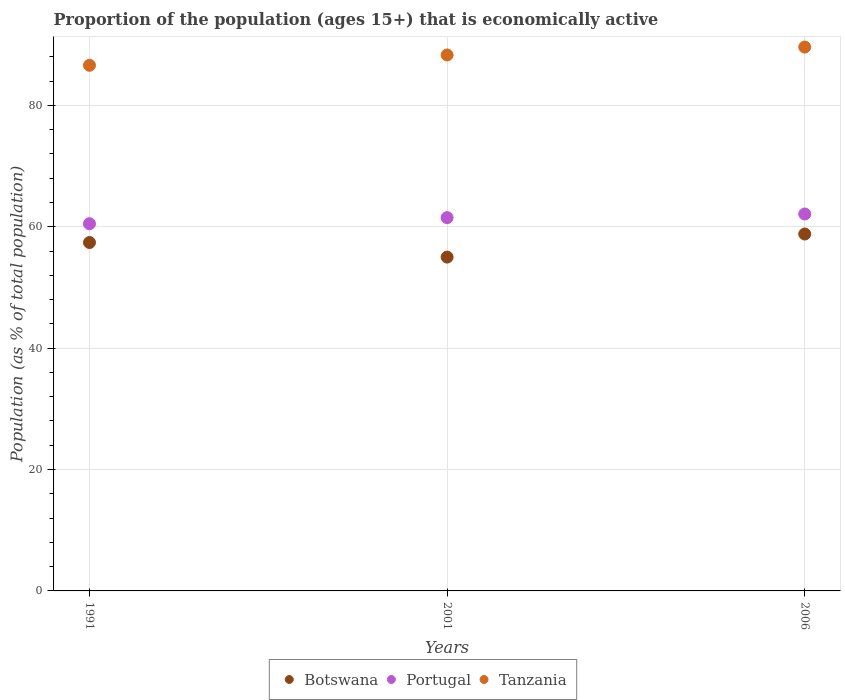How many different coloured dotlines are there?
Your answer should be compact. 3. What is the proportion of the population that is economically active in Botswana in 2006?
Your answer should be very brief. 58.8. Across all years, what is the maximum proportion of the population that is economically active in Tanzania?
Provide a succinct answer. 89.6. Across all years, what is the minimum proportion of the population that is economically active in Portugal?
Keep it short and to the point. 60.5. What is the total proportion of the population that is economically active in Botswana in the graph?
Provide a short and direct response. 171.2. What is the difference between the proportion of the population that is economically active in Tanzania in 2001 and that in 2006?
Make the answer very short. -1.3. What is the difference between the proportion of the population that is economically active in Portugal in 1991 and the proportion of the population that is economically active in Tanzania in 2001?
Make the answer very short. -27.8. What is the average proportion of the population that is economically active in Tanzania per year?
Offer a very short reply. 88.17. In the year 1991, what is the difference between the proportion of the population that is economically active in Botswana and proportion of the population that is economically active in Tanzania?
Provide a succinct answer. -29.2. In how many years, is the proportion of the population that is economically active in Tanzania greater than 8 %?
Ensure brevity in your answer.  3. What is the ratio of the proportion of the population that is economically active in Portugal in 1991 to that in 2006?
Your answer should be compact. 0.97. Is the proportion of the population that is economically active in Botswana in 1991 less than that in 2006?
Ensure brevity in your answer.  Yes. What is the difference between the highest and the second highest proportion of the population that is economically active in Portugal?
Provide a short and direct response. 0.6. What is the difference between the highest and the lowest proportion of the population that is economically active in Botswana?
Ensure brevity in your answer.  3.8. In how many years, is the proportion of the population that is economically active in Tanzania greater than the average proportion of the population that is economically active in Tanzania taken over all years?
Keep it short and to the point. 2. Is the sum of the proportion of the population that is economically active in Portugal in 1991 and 2006 greater than the maximum proportion of the population that is economically active in Botswana across all years?
Offer a very short reply. Yes. How many years are there in the graph?
Your answer should be very brief. 3. What is the difference between two consecutive major ticks on the Y-axis?
Provide a short and direct response. 20. How are the legend labels stacked?
Provide a succinct answer. Horizontal. What is the title of the graph?
Your answer should be compact. Proportion of the population (ages 15+) that is economically active. Does "Mexico" appear as one of the legend labels in the graph?
Keep it short and to the point. No. What is the label or title of the X-axis?
Provide a succinct answer. Years. What is the label or title of the Y-axis?
Your answer should be compact. Population (as % of total population). What is the Population (as % of total population) in Botswana in 1991?
Ensure brevity in your answer.  57.4. What is the Population (as % of total population) of Portugal in 1991?
Your response must be concise. 60.5. What is the Population (as % of total population) in Tanzania in 1991?
Keep it short and to the point. 86.6. What is the Population (as % of total population) of Portugal in 2001?
Make the answer very short. 61.5. What is the Population (as % of total population) in Tanzania in 2001?
Your answer should be compact. 88.3. What is the Population (as % of total population) in Botswana in 2006?
Your answer should be very brief. 58.8. What is the Population (as % of total population) in Portugal in 2006?
Provide a short and direct response. 62.1. What is the Population (as % of total population) of Tanzania in 2006?
Provide a short and direct response. 89.6. Across all years, what is the maximum Population (as % of total population) in Botswana?
Make the answer very short. 58.8. Across all years, what is the maximum Population (as % of total population) of Portugal?
Your response must be concise. 62.1. Across all years, what is the maximum Population (as % of total population) of Tanzania?
Make the answer very short. 89.6. Across all years, what is the minimum Population (as % of total population) in Portugal?
Your response must be concise. 60.5. Across all years, what is the minimum Population (as % of total population) of Tanzania?
Ensure brevity in your answer.  86.6. What is the total Population (as % of total population) of Botswana in the graph?
Keep it short and to the point. 171.2. What is the total Population (as % of total population) in Portugal in the graph?
Offer a terse response. 184.1. What is the total Population (as % of total population) of Tanzania in the graph?
Make the answer very short. 264.5. What is the difference between the Population (as % of total population) of Botswana in 1991 and that in 2001?
Provide a succinct answer. 2.4. What is the difference between the Population (as % of total population) in Tanzania in 1991 and that in 2001?
Offer a terse response. -1.7. What is the difference between the Population (as % of total population) of Botswana in 1991 and that in 2006?
Keep it short and to the point. -1.4. What is the difference between the Population (as % of total population) of Portugal in 1991 and that in 2006?
Your response must be concise. -1.6. What is the difference between the Population (as % of total population) in Tanzania in 1991 and that in 2006?
Ensure brevity in your answer.  -3. What is the difference between the Population (as % of total population) of Botswana in 2001 and that in 2006?
Make the answer very short. -3.8. What is the difference between the Population (as % of total population) in Botswana in 1991 and the Population (as % of total population) in Tanzania in 2001?
Provide a succinct answer. -30.9. What is the difference between the Population (as % of total population) of Portugal in 1991 and the Population (as % of total population) of Tanzania in 2001?
Give a very brief answer. -27.8. What is the difference between the Population (as % of total population) of Botswana in 1991 and the Population (as % of total population) of Portugal in 2006?
Ensure brevity in your answer.  -4.7. What is the difference between the Population (as % of total population) in Botswana in 1991 and the Population (as % of total population) in Tanzania in 2006?
Ensure brevity in your answer.  -32.2. What is the difference between the Population (as % of total population) in Portugal in 1991 and the Population (as % of total population) in Tanzania in 2006?
Provide a short and direct response. -29.1. What is the difference between the Population (as % of total population) of Botswana in 2001 and the Population (as % of total population) of Portugal in 2006?
Your answer should be very brief. -7.1. What is the difference between the Population (as % of total population) in Botswana in 2001 and the Population (as % of total population) in Tanzania in 2006?
Your response must be concise. -34.6. What is the difference between the Population (as % of total population) of Portugal in 2001 and the Population (as % of total population) of Tanzania in 2006?
Offer a very short reply. -28.1. What is the average Population (as % of total population) in Botswana per year?
Offer a terse response. 57.07. What is the average Population (as % of total population) of Portugal per year?
Your answer should be compact. 61.37. What is the average Population (as % of total population) of Tanzania per year?
Provide a short and direct response. 88.17. In the year 1991, what is the difference between the Population (as % of total population) of Botswana and Population (as % of total population) of Tanzania?
Your answer should be compact. -29.2. In the year 1991, what is the difference between the Population (as % of total population) of Portugal and Population (as % of total population) of Tanzania?
Keep it short and to the point. -26.1. In the year 2001, what is the difference between the Population (as % of total population) of Botswana and Population (as % of total population) of Portugal?
Give a very brief answer. -6.5. In the year 2001, what is the difference between the Population (as % of total population) in Botswana and Population (as % of total population) in Tanzania?
Your answer should be very brief. -33.3. In the year 2001, what is the difference between the Population (as % of total population) in Portugal and Population (as % of total population) in Tanzania?
Your answer should be very brief. -26.8. In the year 2006, what is the difference between the Population (as % of total population) of Botswana and Population (as % of total population) of Tanzania?
Give a very brief answer. -30.8. In the year 2006, what is the difference between the Population (as % of total population) of Portugal and Population (as % of total population) of Tanzania?
Offer a terse response. -27.5. What is the ratio of the Population (as % of total population) of Botswana in 1991 to that in 2001?
Make the answer very short. 1.04. What is the ratio of the Population (as % of total population) of Portugal in 1991 to that in 2001?
Make the answer very short. 0.98. What is the ratio of the Population (as % of total population) of Tanzania in 1991 to that in 2001?
Your answer should be very brief. 0.98. What is the ratio of the Population (as % of total population) of Botswana in 1991 to that in 2006?
Your answer should be compact. 0.98. What is the ratio of the Population (as % of total population) of Portugal in 1991 to that in 2006?
Provide a short and direct response. 0.97. What is the ratio of the Population (as % of total population) of Tanzania in 1991 to that in 2006?
Provide a short and direct response. 0.97. What is the ratio of the Population (as % of total population) of Botswana in 2001 to that in 2006?
Offer a terse response. 0.94. What is the ratio of the Population (as % of total population) in Portugal in 2001 to that in 2006?
Your answer should be compact. 0.99. What is the ratio of the Population (as % of total population) in Tanzania in 2001 to that in 2006?
Offer a very short reply. 0.99. What is the difference between the highest and the second highest Population (as % of total population) of Portugal?
Make the answer very short. 0.6. What is the difference between the highest and the lowest Population (as % of total population) of Botswana?
Give a very brief answer. 3.8. 